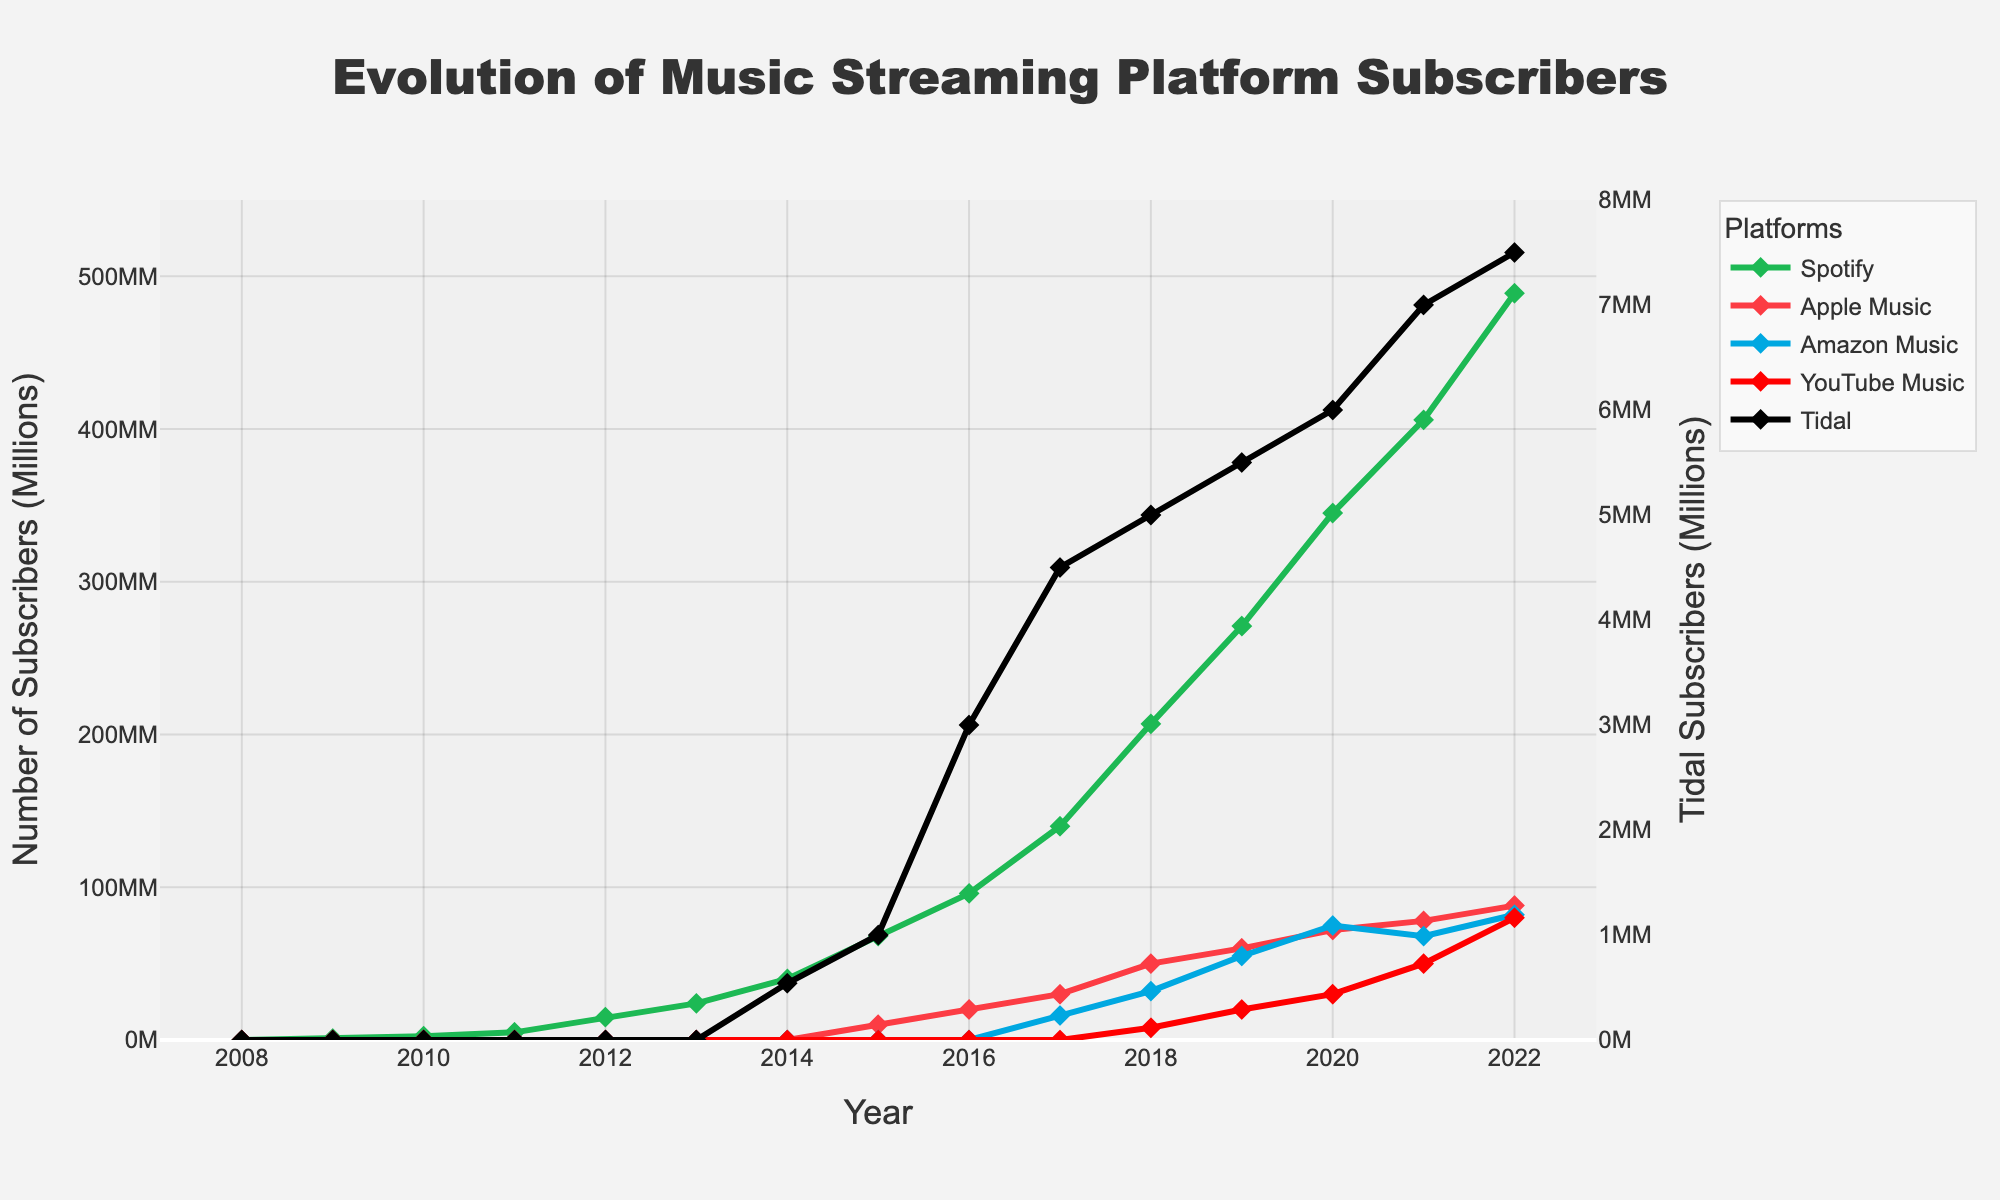Which platform had the highest number of subscribers in 2022? Looking at the end of the chart for the year 2022, we can see that Spotify had the highest subscriber count as its line reaches the highest point compared to other platforms.
Answer: Spotify How many subscribers did Apple Music have in 2018 compared to YouTube Music? In 2018, Apple Music's line is at 50 million subscribers while YouTube Music's line is at 8 million subscribers. Subtracting these values, we get 50 million - 8 million.
Answer: 42 million Between 2009 and 2022, which platform showed the greatest increase in subscriber count? Observing the start and end points of each platform’s line, Spotify has the largest increase, starting from 1 million subscribers in 2009 and reaching 489 million in 2022, which is an increase of 488 million.
Answer: Spotify What is the difference in subscriber count between Amazon Music and Tidal in 2022? In 2022, Amazon Music had 82 million subscribers and Tidal had 7.5 million subscribers. The difference is 82M - 7.5M.
Answer: 74.5 million Which year did Spotify reach 100 million subscribers? Following Spotify's line on the chart, we see it hits the 100 million mark in the year 2016.
Answer: 2016 What was the approximate average number of subscribers for YouTube Music in the years it is listed on the chart? YouTube Music is listed from 2018 to 2022 with subscribers of 8M, 20M, 30M, 50M, and 80M respectively. Summing these: 8 + 20 + 30 + 50 + 80 = 188. The average is 188M / 5 years.
Answer: 37.6 million Which platform had the slowest growth rate from inception to 2022? By examining the slopes of the lines, Tidal shows the slowest growth since its line is the least steep, indicating a smaller increase in subscriber numbers from 540,000 in 2014 to 7.5 million in 2022.
Answer: Tidal 